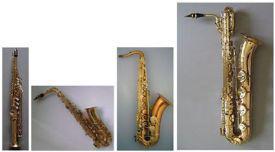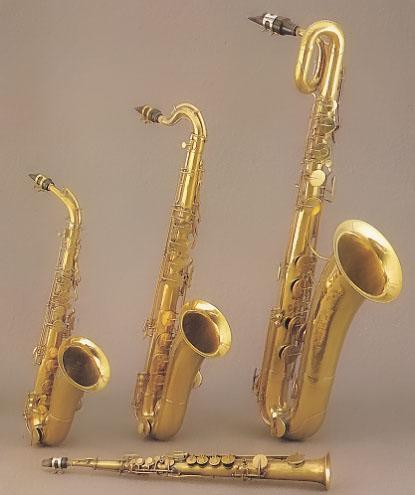The first image is the image on the left, the second image is the image on the right. For the images shown, is this caption "Right and left images each show four instruments, including one that is straight and three with curved mouthpieces and bell ends." true? Answer yes or no. Yes. 